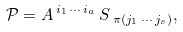Convert formula to latex. <formula><loc_0><loc_0><loc_500><loc_500>\mathcal { P } = A \, ^ { { i _ { 1 } } \, \cdots \, { i _ { a } } } \, S \, { _ { \pi ( { j _ { 1 } } \, \cdots \, { j _ { s } } ) } } ,</formula> 